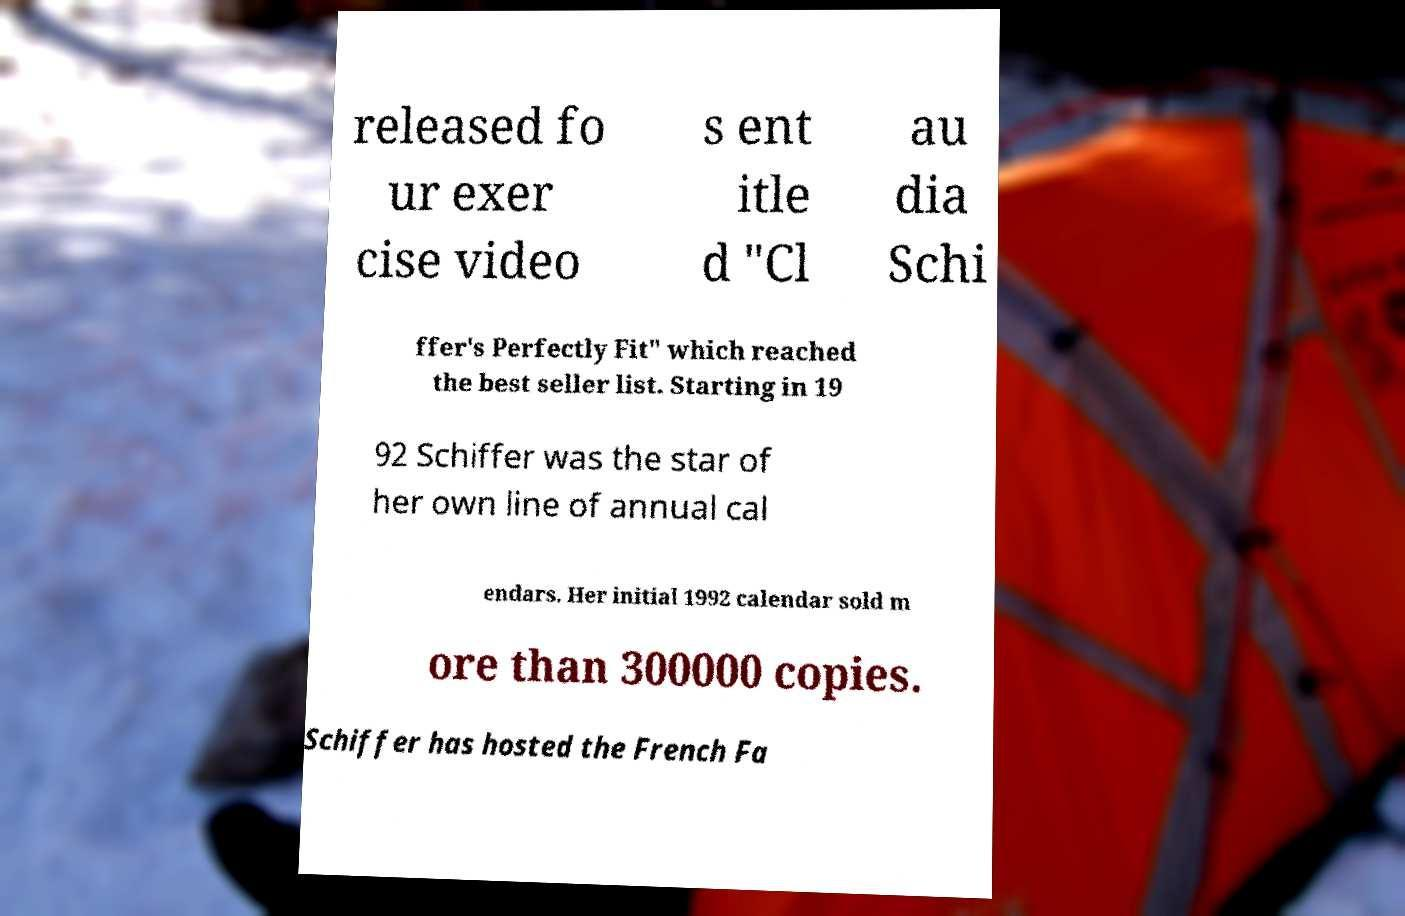What messages or text are displayed in this image? I need them in a readable, typed format. released fo ur exer cise video s ent itle d "Cl au dia Schi ffer's Perfectly Fit" which reached the best seller list. Starting in 19 92 Schiffer was the star of her own line of annual cal endars. Her initial 1992 calendar sold m ore than 300000 copies. Schiffer has hosted the French Fa 